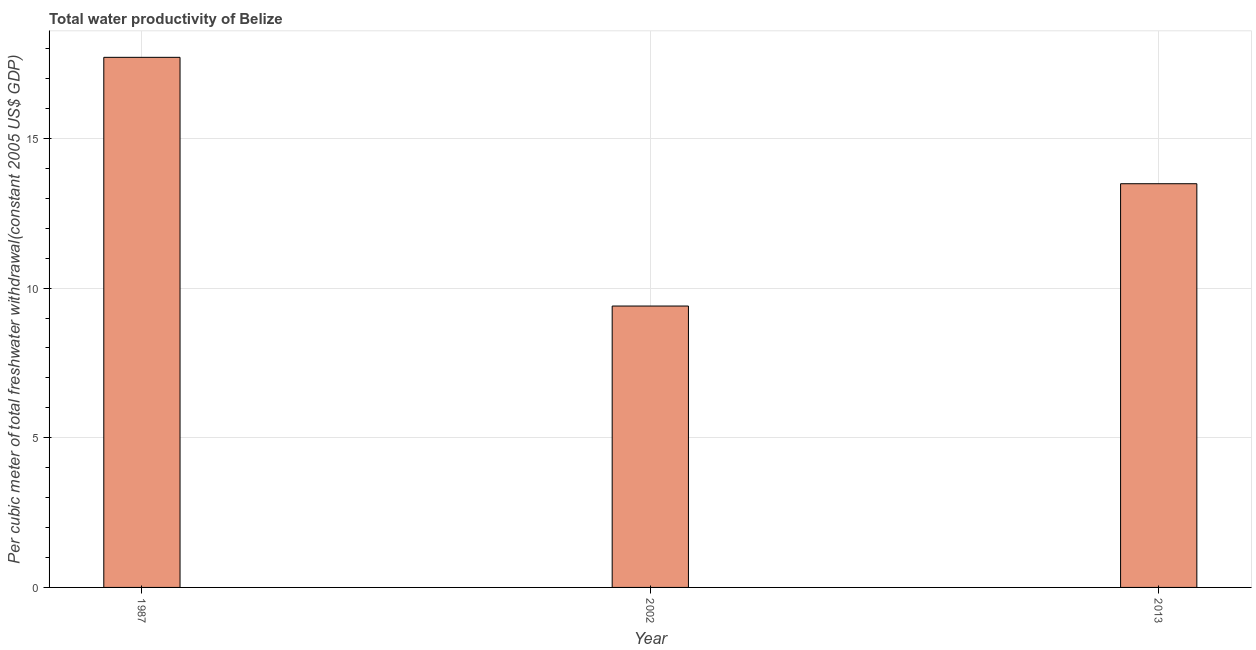Does the graph contain any zero values?
Provide a succinct answer. No. Does the graph contain grids?
Make the answer very short. Yes. What is the title of the graph?
Keep it short and to the point. Total water productivity of Belize. What is the label or title of the Y-axis?
Offer a terse response. Per cubic meter of total freshwater withdrawal(constant 2005 US$ GDP). What is the total water productivity in 1987?
Provide a short and direct response. 17.71. Across all years, what is the maximum total water productivity?
Offer a very short reply. 17.71. Across all years, what is the minimum total water productivity?
Keep it short and to the point. 9.4. What is the sum of the total water productivity?
Your answer should be very brief. 40.59. What is the difference between the total water productivity in 1987 and 2002?
Provide a short and direct response. 8.31. What is the average total water productivity per year?
Give a very brief answer. 13.53. What is the median total water productivity?
Your answer should be compact. 13.49. Do a majority of the years between 1987 and 2013 (inclusive) have total water productivity greater than 12 US$?
Keep it short and to the point. Yes. What is the ratio of the total water productivity in 1987 to that in 2002?
Ensure brevity in your answer.  1.88. What is the difference between the highest and the second highest total water productivity?
Offer a very short reply. 4.22. What is the difference between the highest and the lowest total water productivity?
Keep it short and to the point. 8.31. In how many years, is the total water productivity greater than the average total water productivity taken over all years?
Provide a succinct answer. 1. How many years are there in the graph?
Your answer should be compact. 3. What is the Per cubic meter of total freshwater withdrawal(constant 2005 US$ GDP) in 1987?
Your response must be concise. 17.71. What is the Per cubic meter of total freshwater withdrawal(constant 2005 US$ GDP) of 2002?
Provide a short and direct response. 9.4. What is the Per cubic meter of total freshwater withdrawal(constant 2005 US$ GDP) in 2013?
Your response must be concise. 13.49. What is the difference between the Per cubic meter of total freshwater withdrawal(constant 2005 US$ GDP) in 1987 and 2002?
Your response must be concise. 8.31. What is the difference between the Per cubic meter of total freshwater withdrawal(constant 2005 US$ GDP) in 1987 and 2013?
Your answer should be very brief. 4.22. What is the difference between the Per cubic meter of total freshwater withdrawal(constant 2005 US$ GDP) in 2002 and 2013?
Provide a short and direct response. -4.09. What is the ratio of the Per cubic meter of total freshwater withdrawal(constant 2005 US$ GDP) in 1987 to that in 2002?
Ensure brevity in your answer.  1.88. What is the ratio of the Per cubic meter of total freshwater withdrawal(constant 2005 US$ GDP) in 1987 to that in 2013?
Offer a very short reply. 1.31. What is the ratio of the Per cubic meter of total freshwater withdrawal(constant 2005 US$ GDP) in 2002 to that in 2013?
Ensure brevity in your answer.  0.7. 